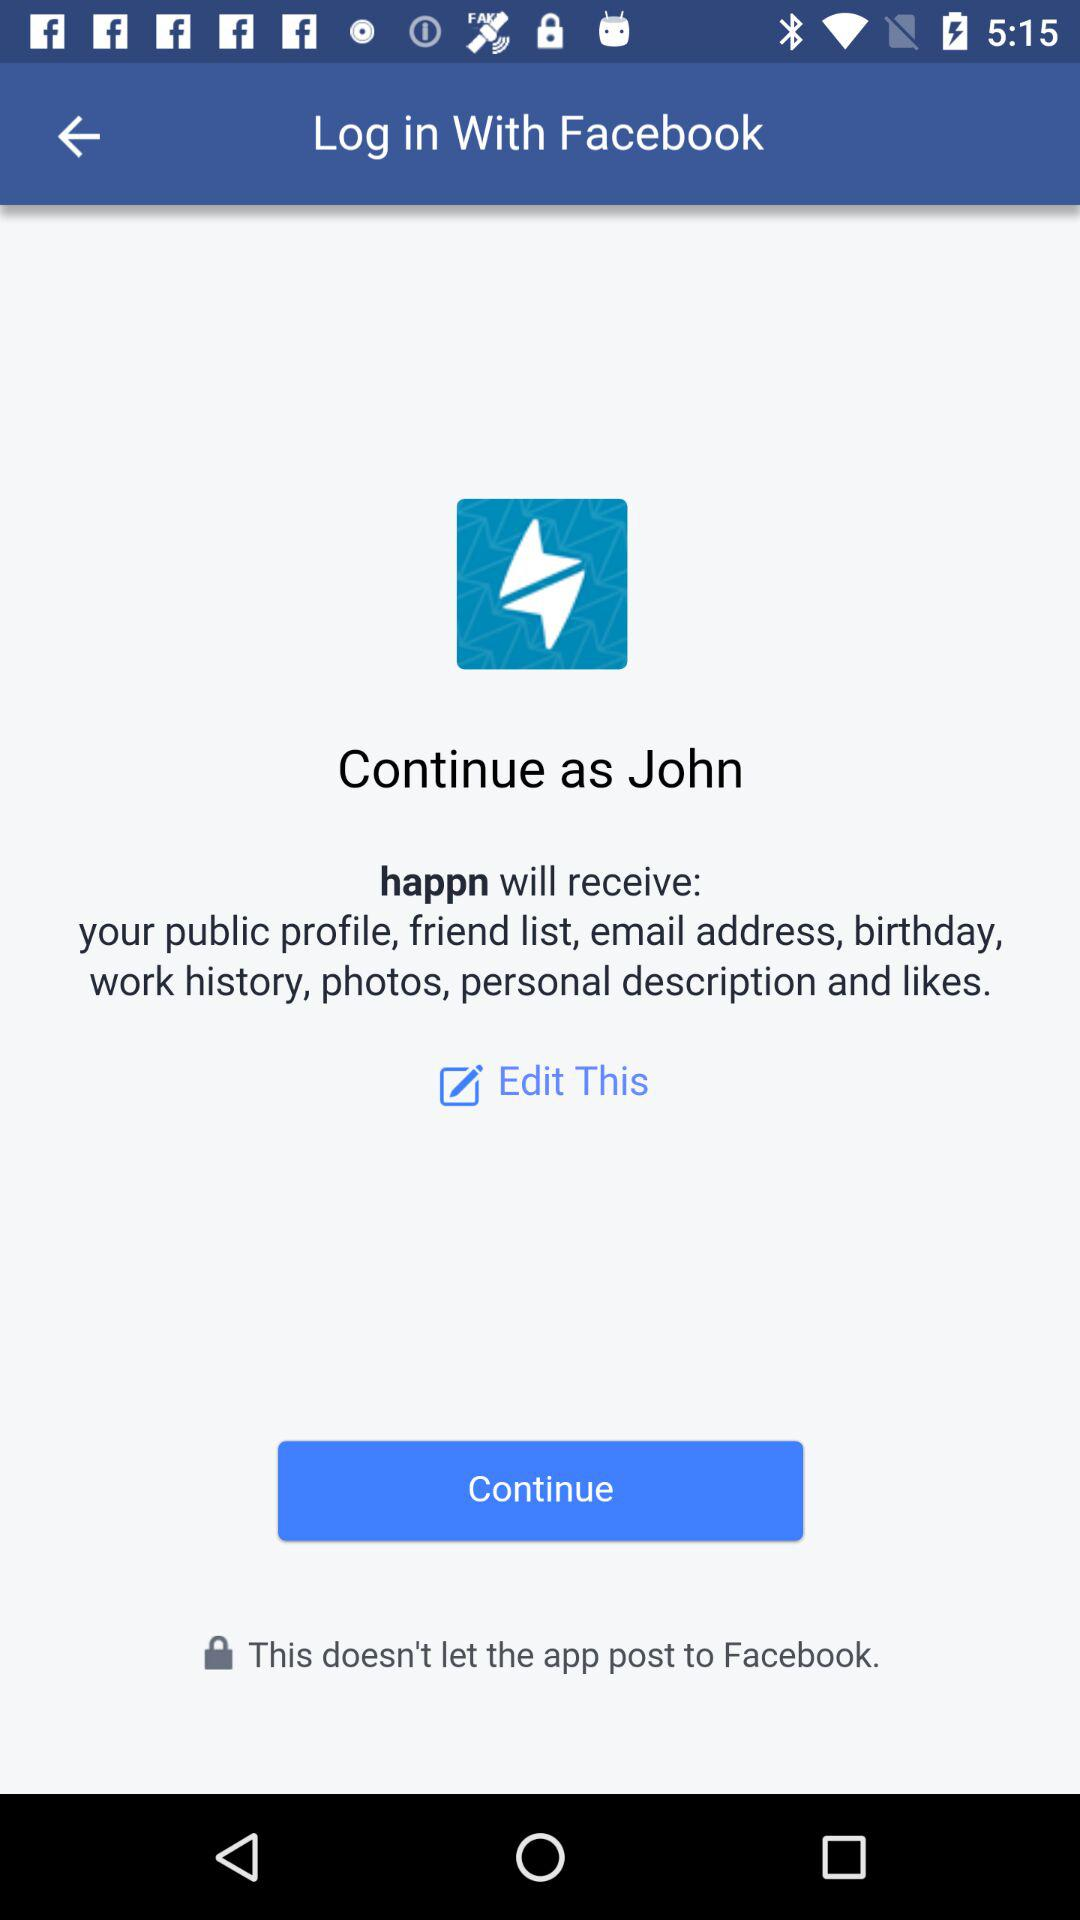What application is asking for permission? The application asking for permission is "happn". 